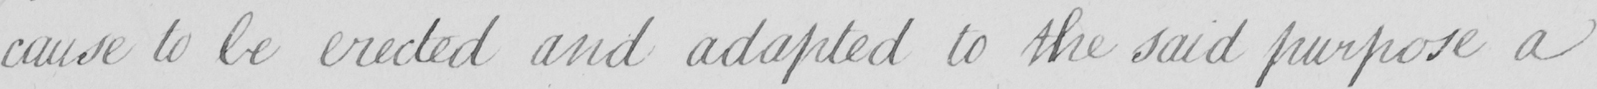Can you tell me what this handwritten text says? cause to be erected and adapted to the said purpose a 